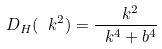<formula> <loc_0><loc_0><loc_500><loc_500>\ D _ { H } ( \ k ^ { 2 } ) = \frac { \ k ^ { 2 } } { \ k ^ { 4 } + b ^ { 4 } }</formula> 